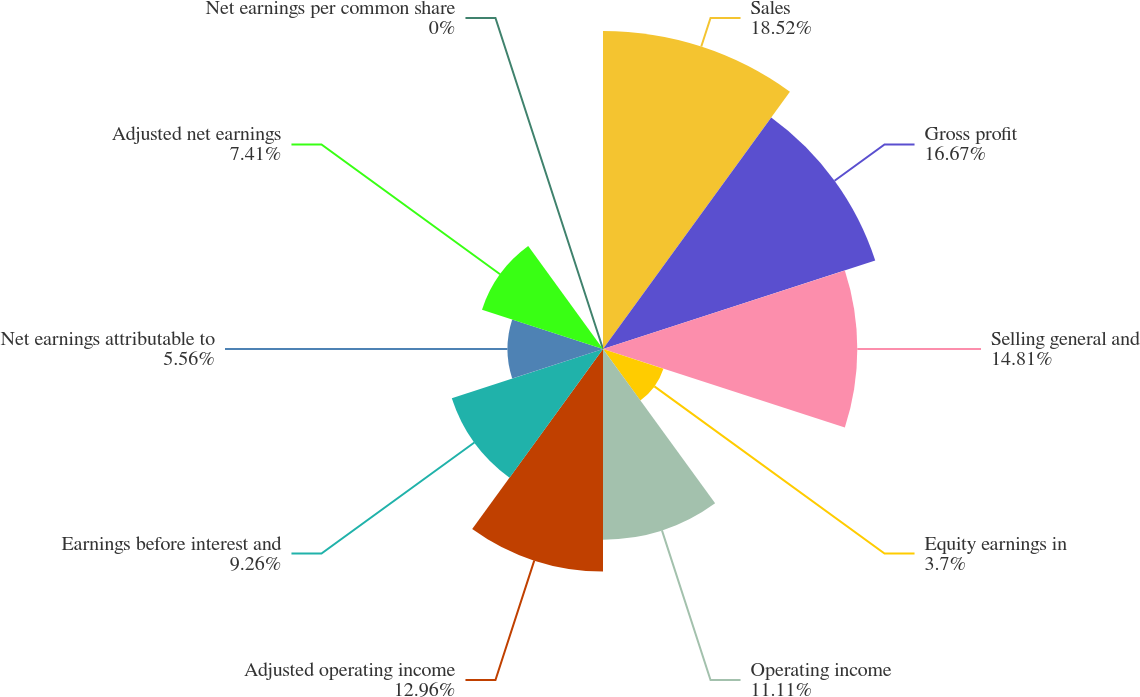Convert chart to OTSL. <chart><loc_0><loc_0><loc_500><loc_500><pie_chart><fcel>Sales<fcel>Gross profit<fcel>Selling general and<fcel>Equity earnings in<fcel>Operating income<fcel>Adjusted operating income<fcel>Earnings before interest and<fcel>Net earnings attributable to<fcel>Adjusted net earnings<fcel>Net earnings per common share<nl><fcel>18.52%<fcel>16.67%<fcel>14.81%<fcel>3.7%<fcel>11.11%<fcel>12.96%<fcel>9.26%<fcel>5.56%<fcel>7.41%<fcel>0.0%<nl></chart> 